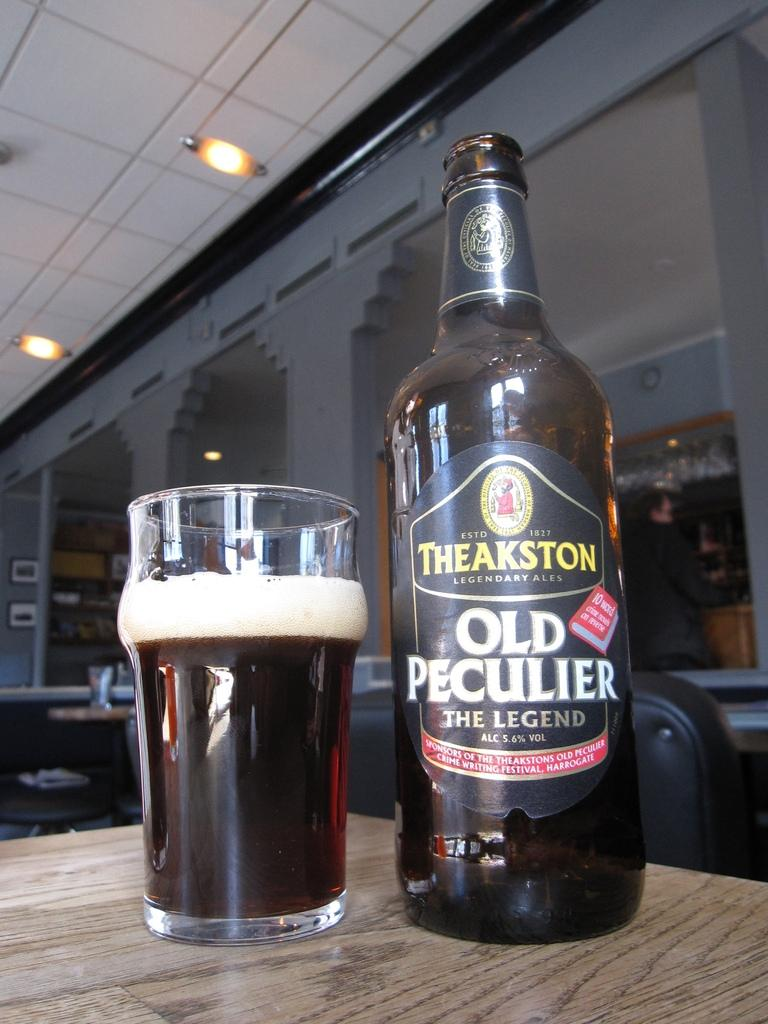<image>
Describe the image concisely. a bottle of theakston old peculier the legend standing next to a glass filled with it 